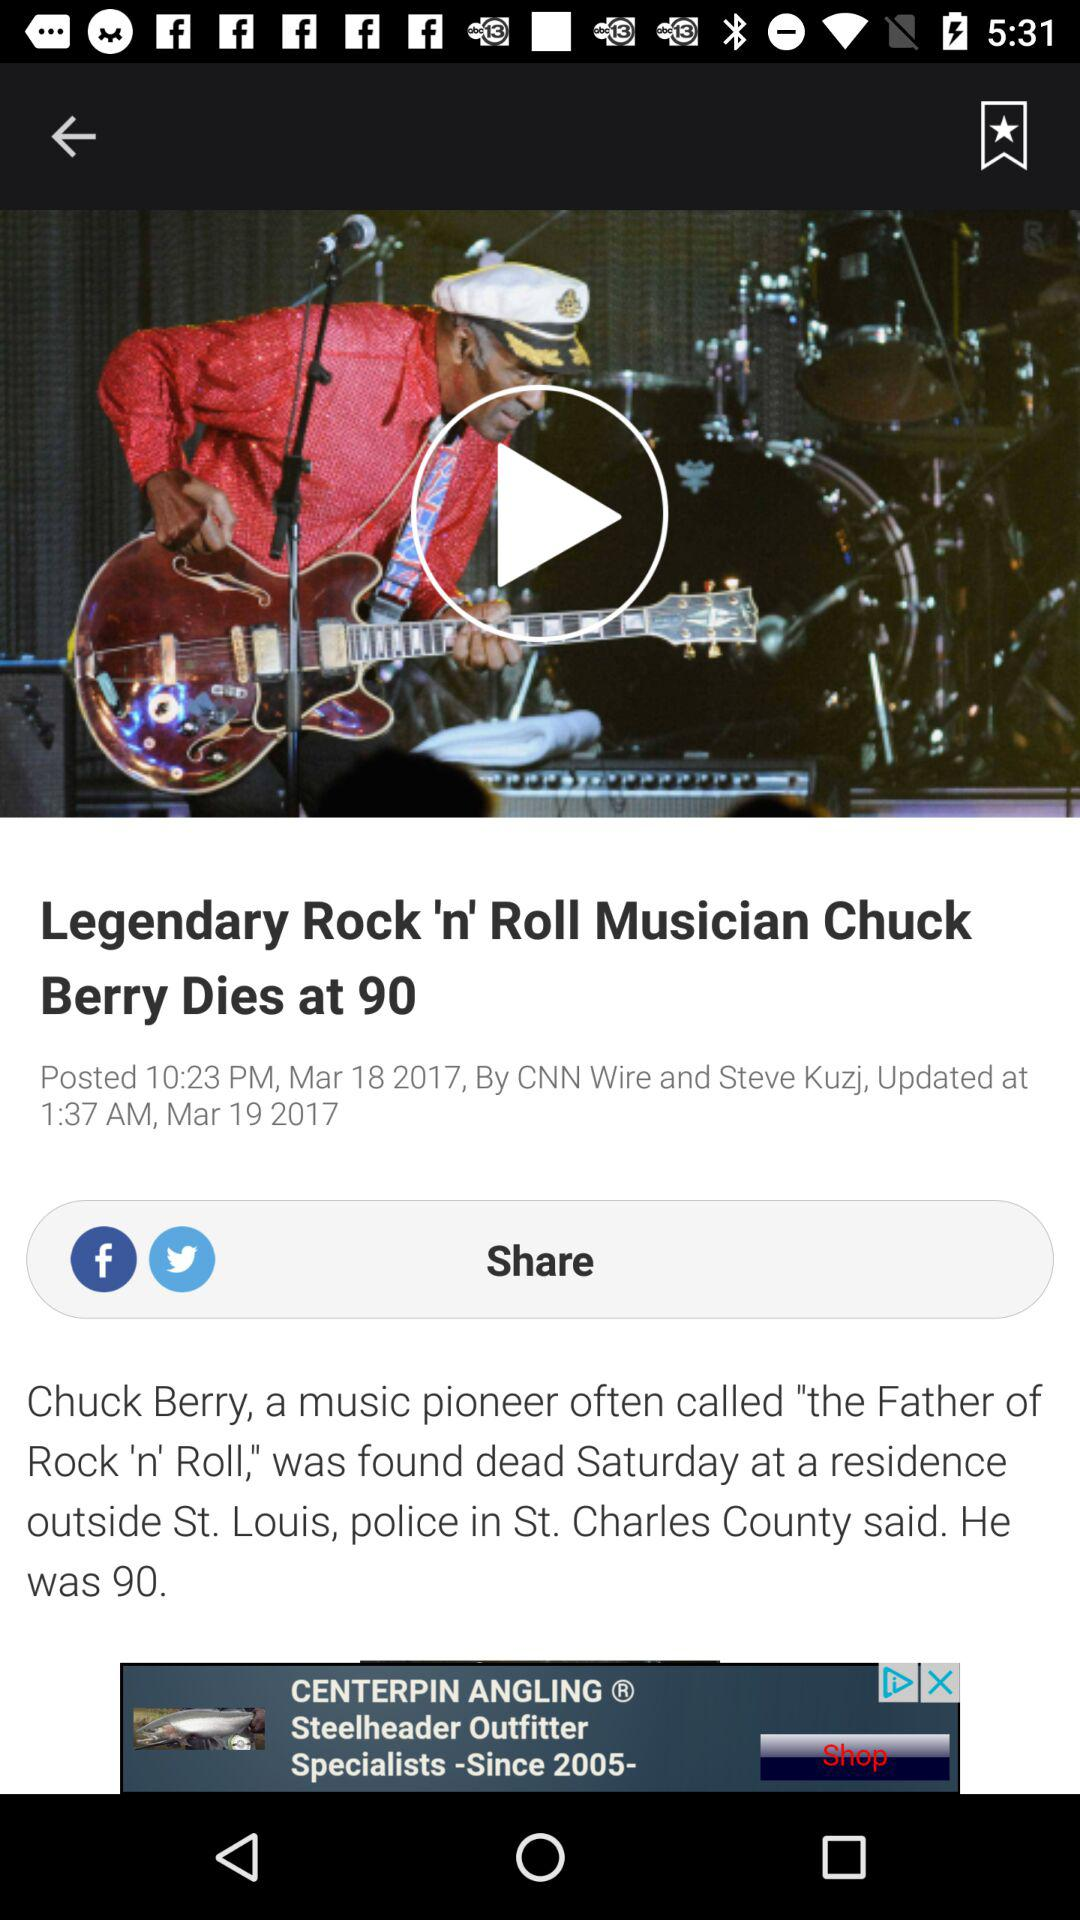When was the news posted? The news was posted on March 18, 2017 at 10:23 p.m. 